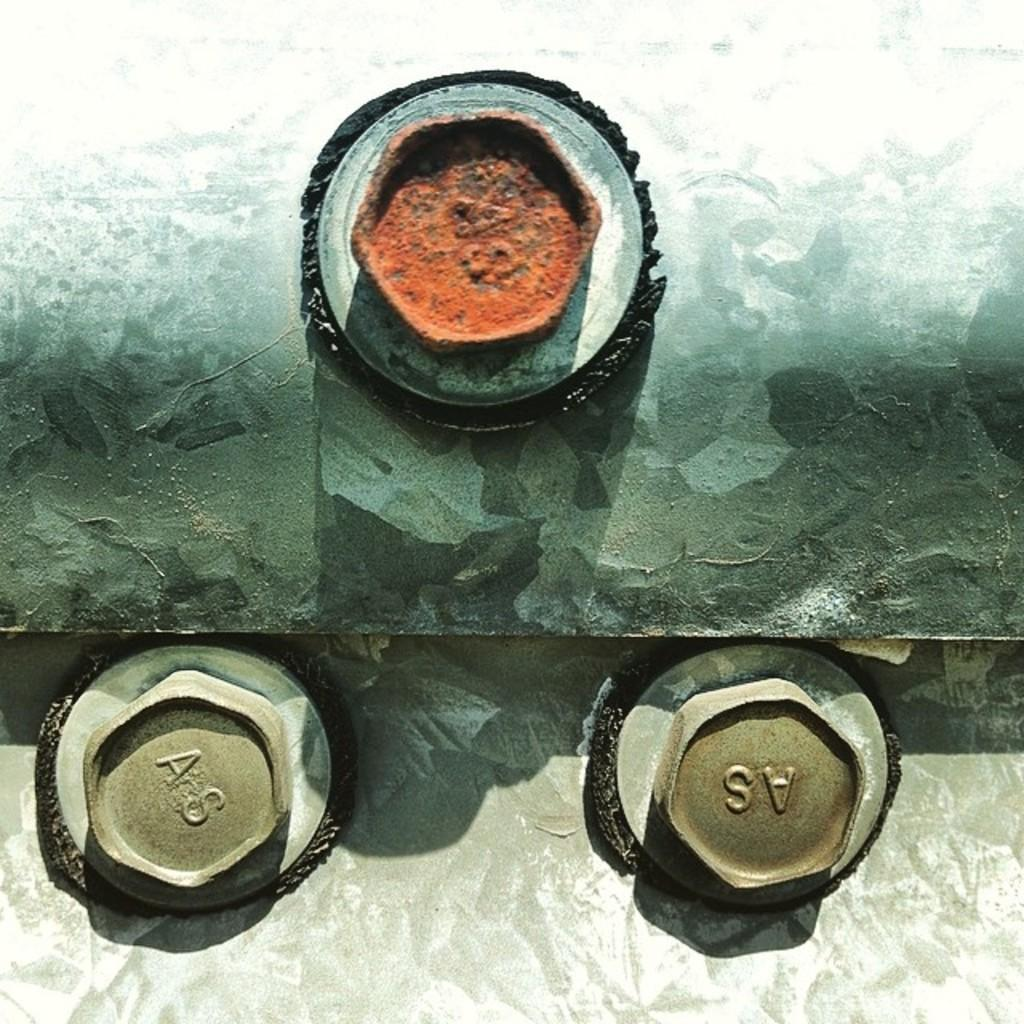What type of object is made of iron in the image? The iron object in the image is not specified, but it is present. What type of fasteners can be seen in the image? There are bolts in the image. What hobbies can be seen being practiced in the image? There is no indication of any hobbies being practiced in the image; it only features an iron object and bolts. What type of cloud is visible in the image? There is no cloud visible in the image, as it only features an iron object and bolts. 